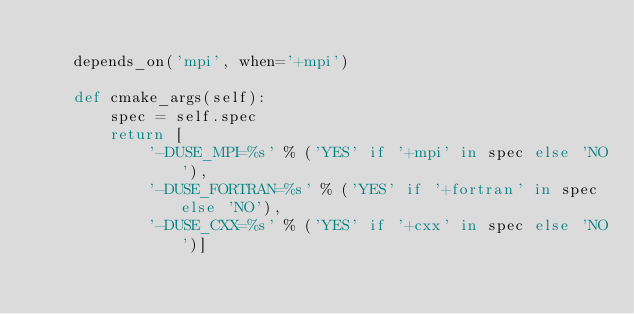<code> <loc_0><loc_0><loc_500><loc_500><_Python_>
    depends_on('mpi', when='+mpi')

    def cmake_args(self):
        spec = self.spec
        return [
            '-DUSE_MPI=%s' % ('YES' if '+mpi' in spec else 'NO'),
            '-DUSE_FORTRAN=%s' % ('YES' if '+fortran' in spec else 'NO'),
            '-DUSE_CXX=%s' % ('YES' if '+cxx' in spec else 'NO')]
</code> 